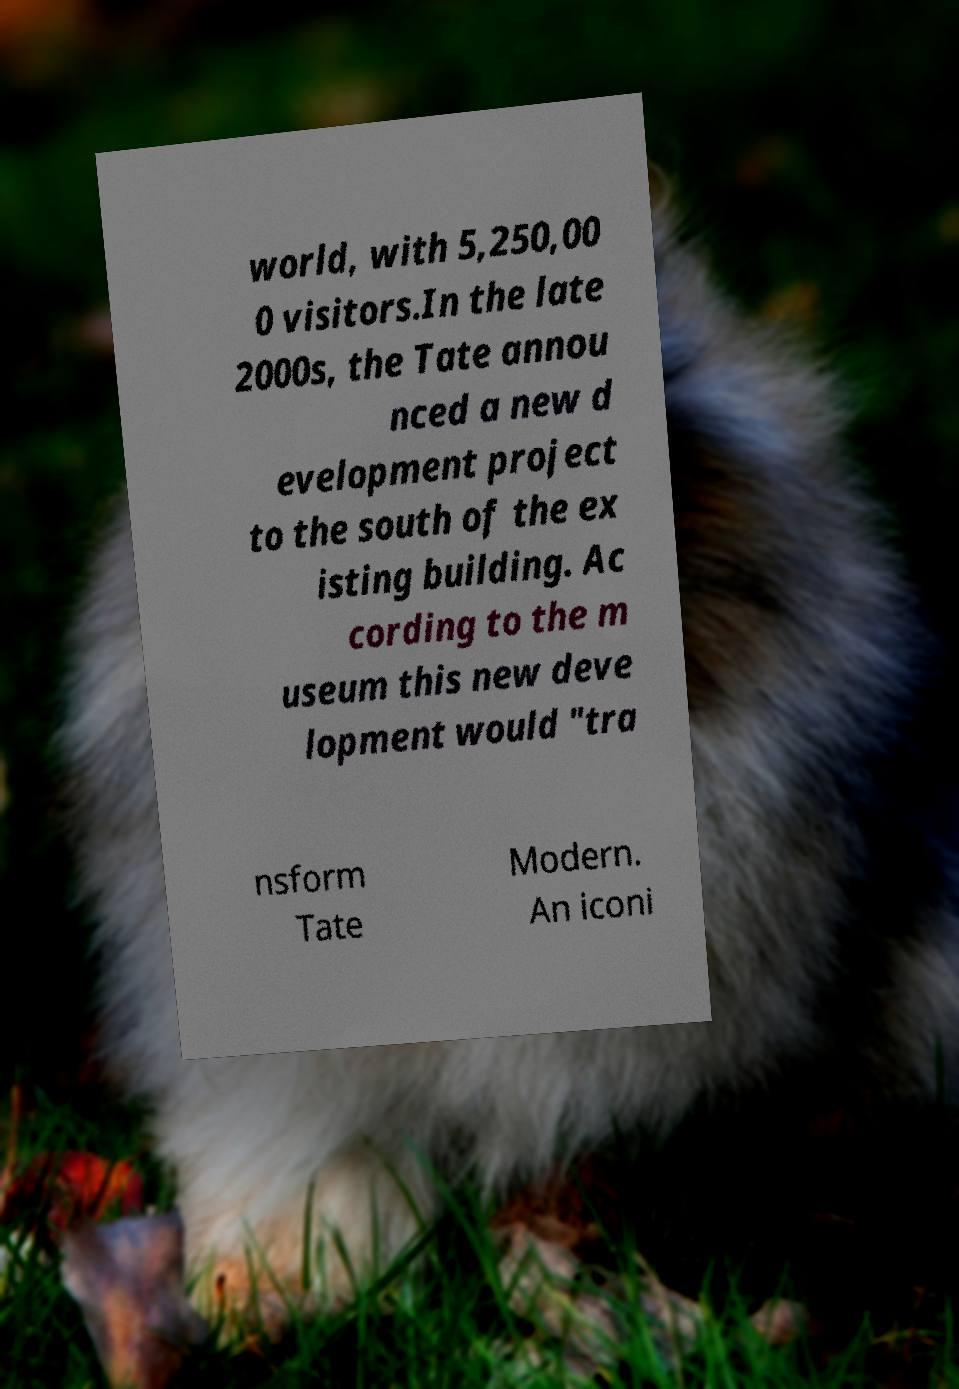Could you assist in decoding the text presented in this image and type it out clearly? world, with 5,250,00 0 visitors.In the late 2000s, the Tate annou nced a new d evelopment project to the south of the ex isting building. Ac cording to the m useum this new deve lopment would "tra nsform Tate Modern. An iconi 